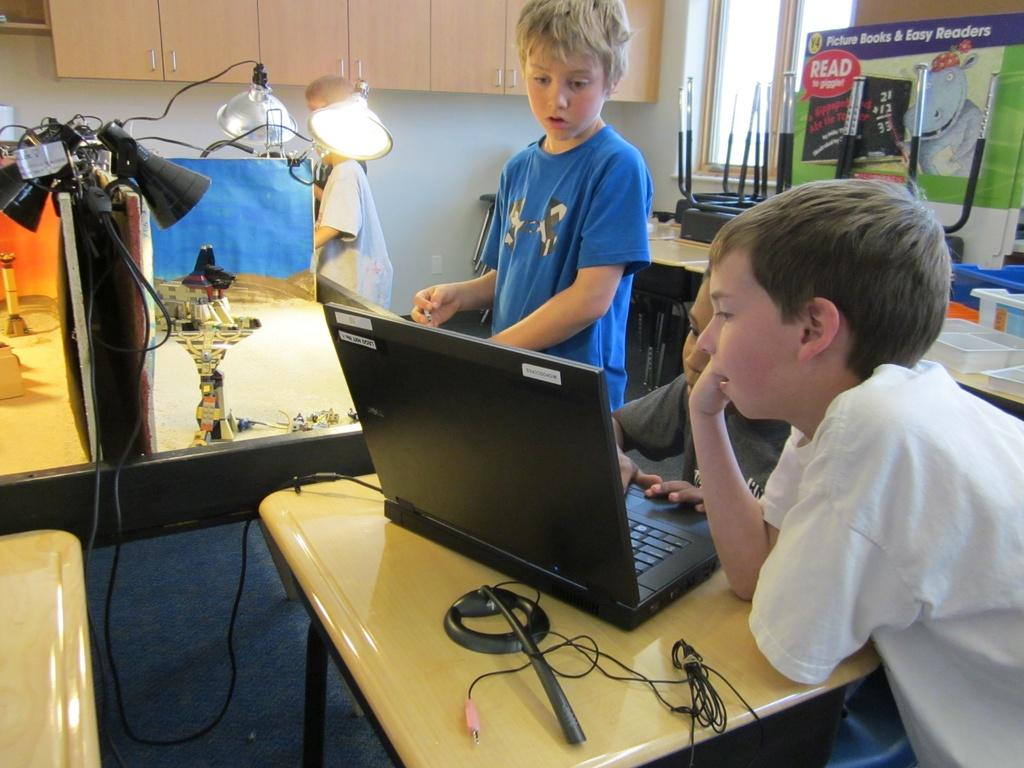Provide a one-sentence caption for the provided image. three kids in front of a computer with a sign behind them that says 'picture books & easy readers'. 